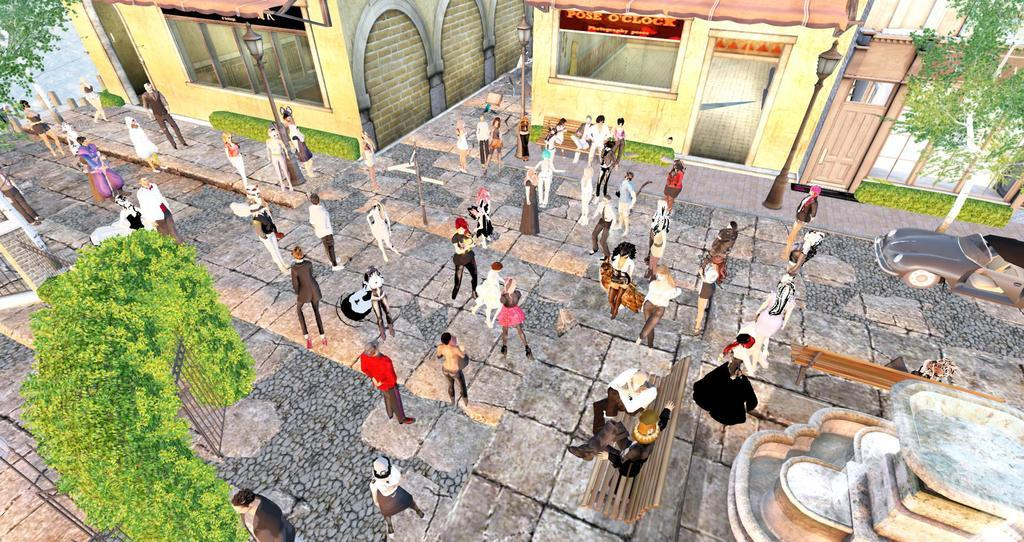How many people are in the image? There is a group of people in the image, but the exact number is not specified. Where are the people standing in the image? The people are standing on the ground in the image. What can be seen in the background of the image? There is a gate, trees, cars, buildings, poles, and a fountain visible in the image. What type of seating is present in the image? Benches are present in the image. What type of match is being played in the image? There is no match being played in the image; it features a group of people standing on the ground with various other elements in the background. What color are the teeth of the person in the image? There are no people in the image with their mouths open, so it is not possible to determine the color of their teeth. 